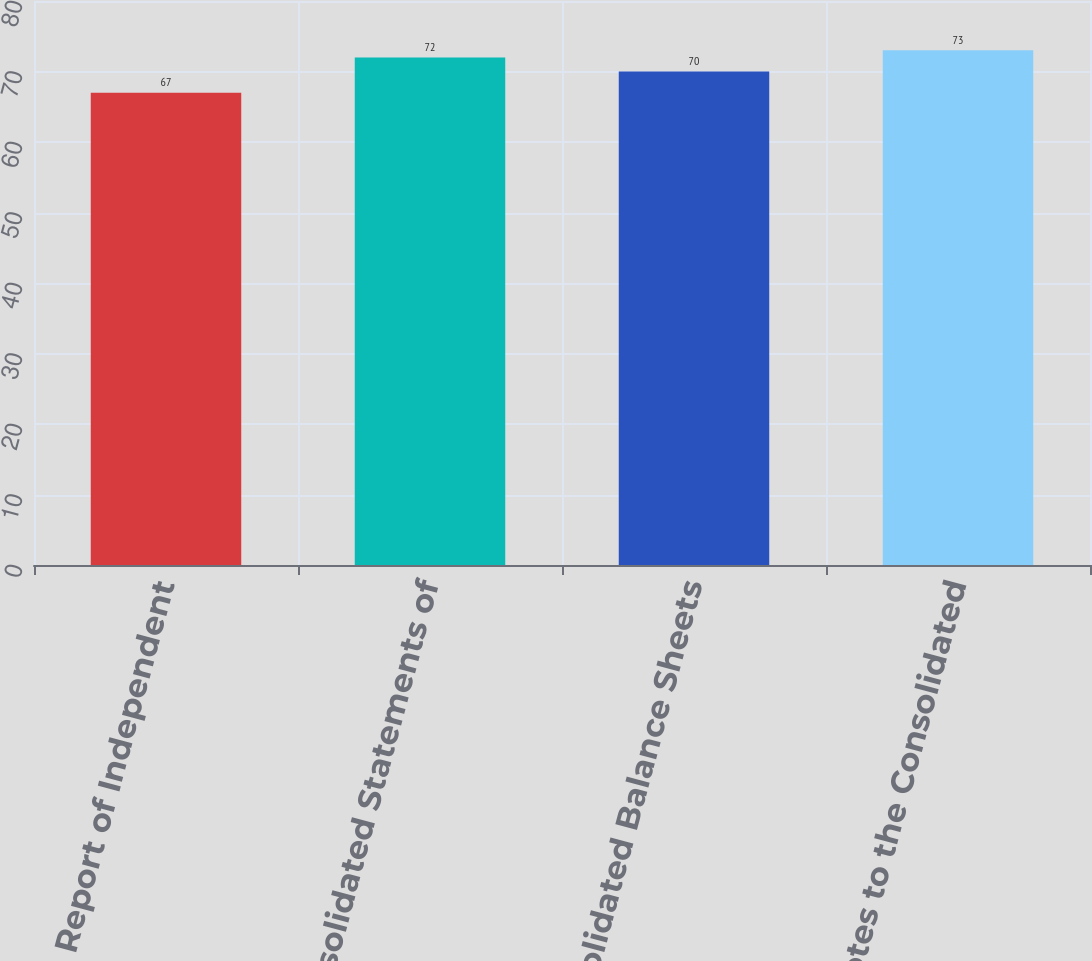Convert chart. <chart><loc_0><loc_0><loc_500><loc_500><bar_chart><fcel>Report of Independent<fcel>Consolidated Statements of<fcel>Consolidated Balance Sheets<fcel>Notes to the Consolidated<nl><fcel>67<fcel>72<fcel>70<fcel>73<nl></chart> 